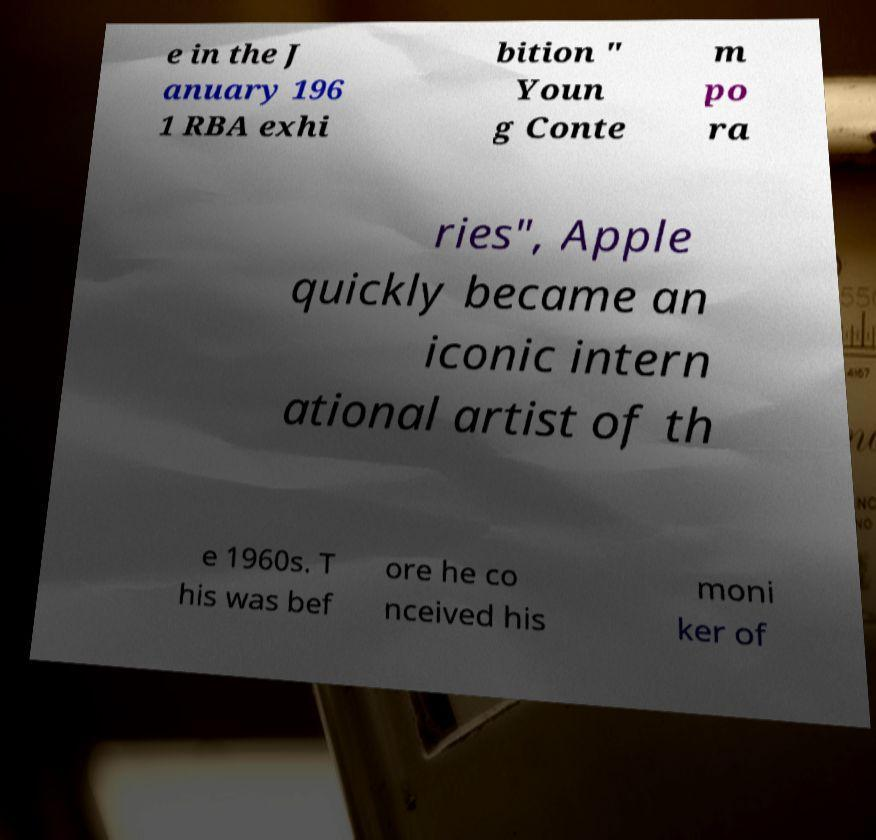I need the written content from this picture converted into text. Can you do that? e in the J anuary 196 1 RBA exhi bition " Youn g Conte m po ra ries", Apple quickly became an iconic intern ational artist of th e 1960s. T his was bef ore he co nceived his moni ker of 